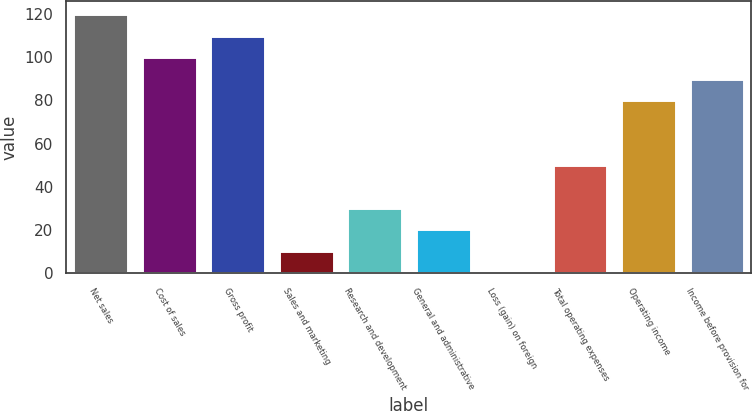Convert chart. <chart><loc_0><loc_0><loc_500><loc_500><bar_chart><fcel>Net sales<fcel>Cost of sales<fcel>Gross profit<fcel>Sales and marketing<fcel>Research and development<fcel>General and administrative<fcel>Loss (gain) on foreign<fcel>Total operating expenses<fcel>Operating income<fcel>Income before provision for<nl><fcel>119.92<fcel>100<fcel>109.96<fcel>10.36<fcel>30.28<fcel>20.32<fcel>0.4<fcel>50.2<fcel>80.08<fcel>90.04<nl></chart> 